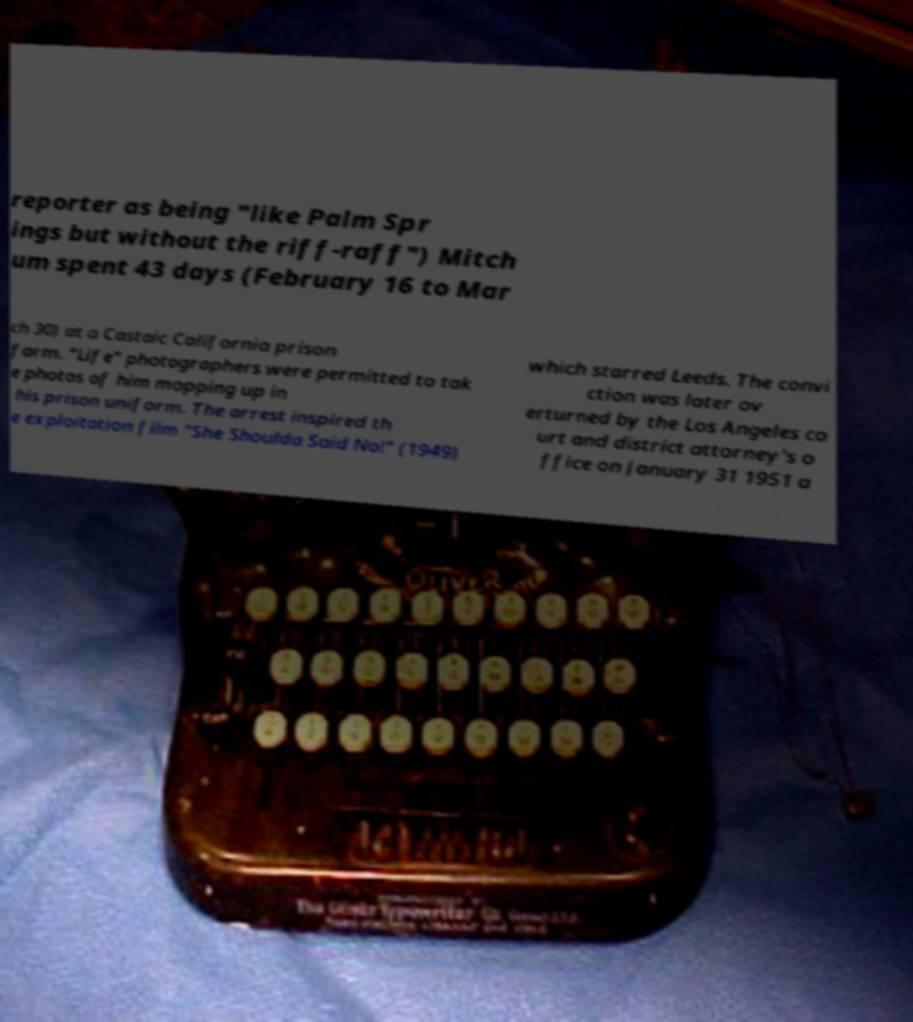Please identify and transcribe the text found in this image. reporter as being "like Palm Spr ings but without the riff-raff") Mitch um spent 43 days (February 16 to Mar ch 30) at a Castaic California prison farm. "Life" photographers were permitted to tak e photos of him mopping up in his prison uniform. The arrest inspired th e exploitation film "She Shoulda Said No!" (1949) which starred Leeds. The convi ction was later ov erturned by the Los Angeles co urt and district attorney's o ffice on January 31 1951 a 